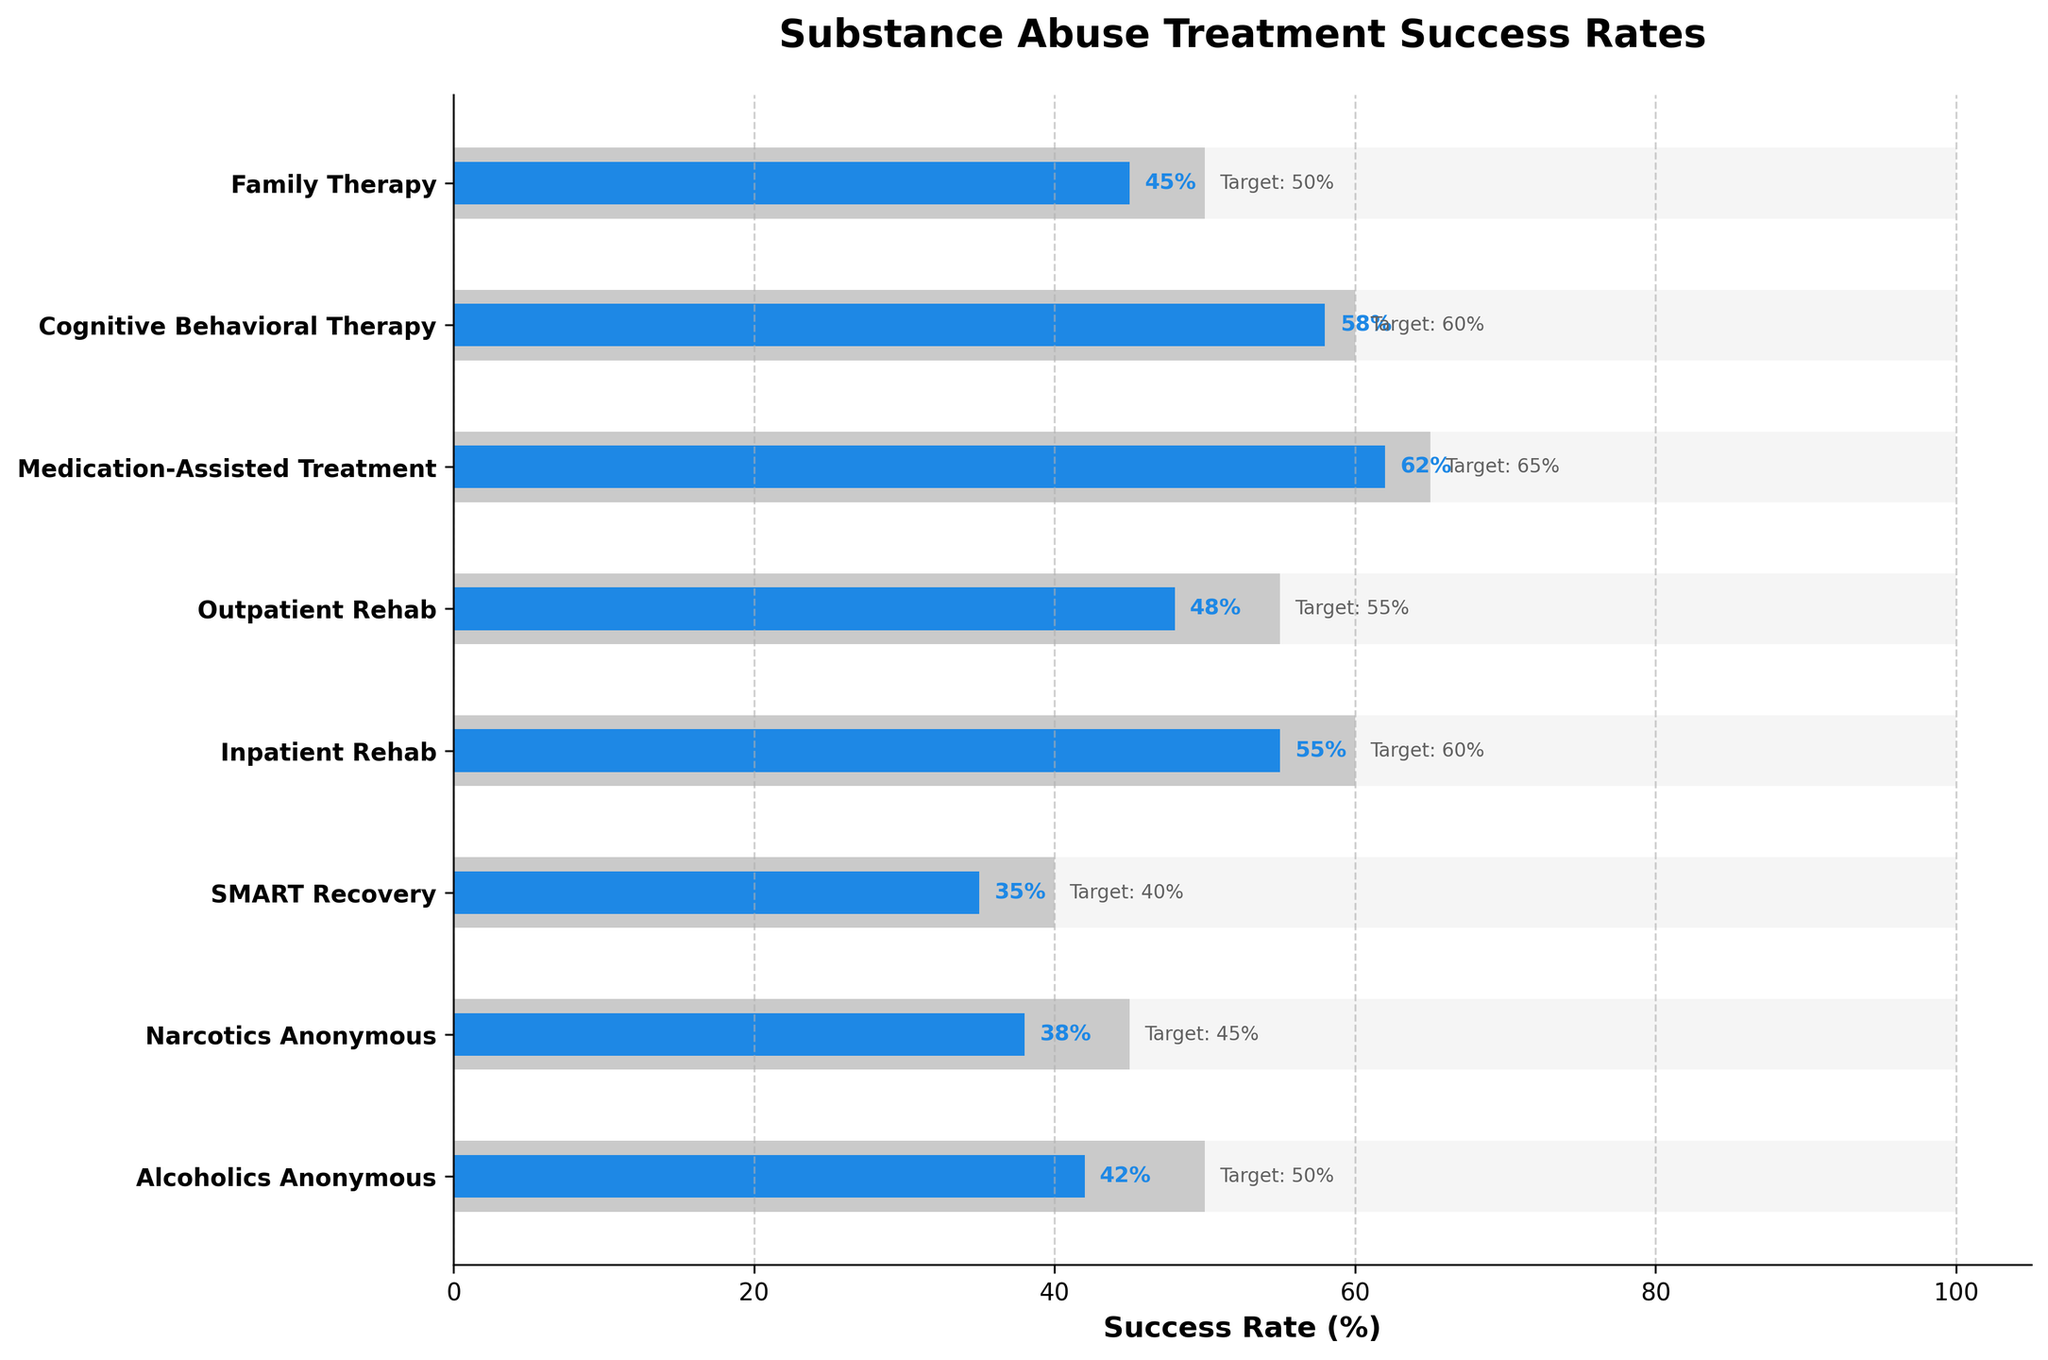What is the title of the chart? The chart's title is found at the top of the figure and summarizes the information being displayed.
Answer: Substance Abuse Treatment Success Rates Which program has the highest actual success rate? By comparing the actual success rates for all programs in the chart, the one with the highest value can be identified.
Answer: Medication-Assisted Treatment Are there any programs where the actual success rate exceeds 50%? Check the actual success rates for all programs and identify those with values greater than 50%.
Answer: Yes, Inpatient Rehab, Medication-Assisted Treatment, and Cognitive Behavioral Therapy What is the difference between the target and actual success rate for Outpatient Rehab? Subtract the actual success rate from the target success rate for Outpatient Rehab (55% - 48%).
Answer: 7% Which program has the smallest gap between its target and actual success rates? Calculate the differences between target and actual success rates for each program and identify the smallest value.
Answer: Cognitive Behavioral Therapy How many programs have an actual success rate above 40%? Count the number of programs where the actual success rate is greater than 40%.
Answer: 5 What is the average actual success rate across all programs? Sum all actual success rates and divide by the number of programs ((42+38+35+55+48+62+58+45)/8).
Answer: 48.13% Which program is the furthest from its target success rate? Determine the program with the largest gap between target and actual success rates.
Answer: SMART Recovery Compare the actual success rates of Alcoholics Anonymous and Narcotics Anonymous. Which one is higher and by how much? Subtract the actual success rate of Narcotics Anonymous from Alcoholics Anonymous (42% - 38%).
Answer: Alcoholics Anonymous is higher by 4% What visual elements represent the maximum success rate in the chart? Identify the visual appearance used to depict the maximum success rate in the chart.
Answer: Light grey bars 